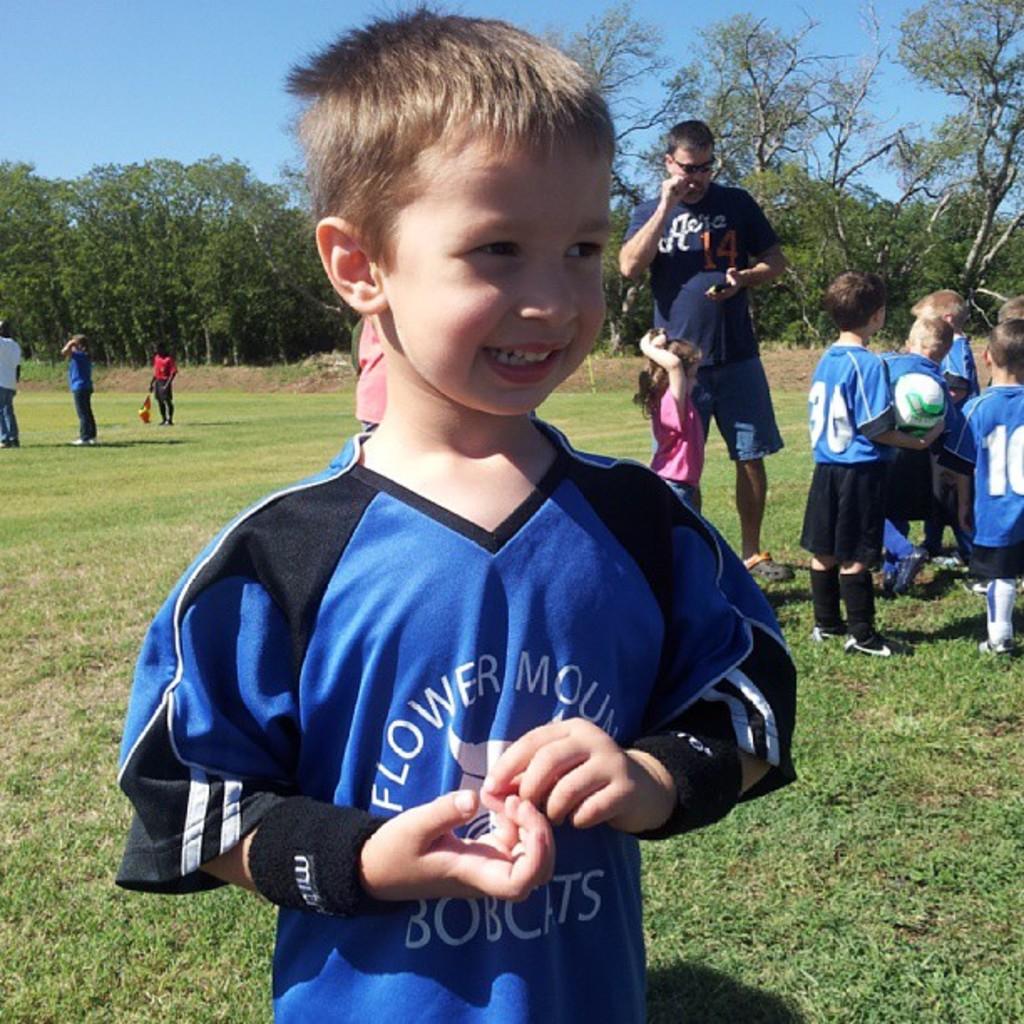What animal is this sports team based off of?
Give a very brief answer. Bobcats. 